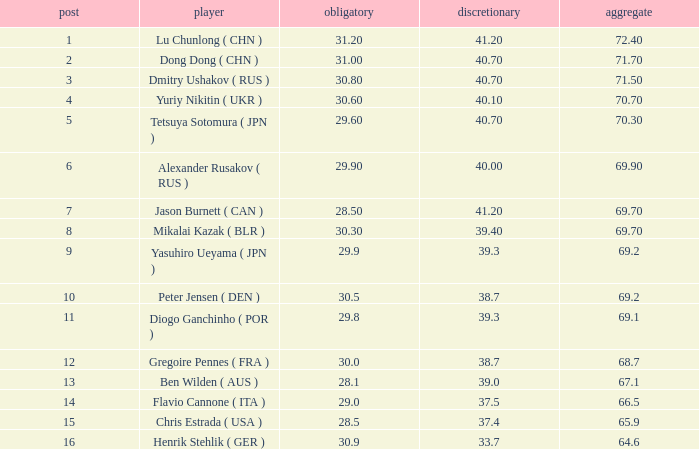What's the position that has a total less than 66.5m, a compulsory of 30.9 and voluntary less than 33.7? None. 